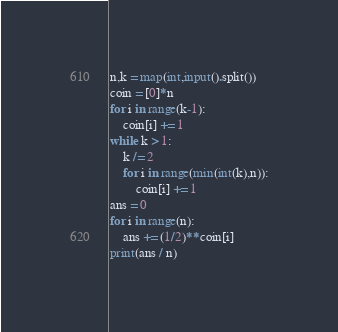Convert code to text. <code><loc_0><loc_0><loc_500><loc_500><_Python_>n,k = map(int,input().split())
coin = [0]*n
for i in range(k-1):
    coin[i] += 1
while k > 1:
    k /= 2
    for i in range(min(int(k),n)):
        coin[i] += 1
ans = 0
for i in range(n):
    ans += (1/2)**coin[i]
print(ans / n)
</code> 